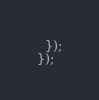<code> <loc_0><loc_0><loc_500><loc_500><_JavaScript_>  });
});
</code> 